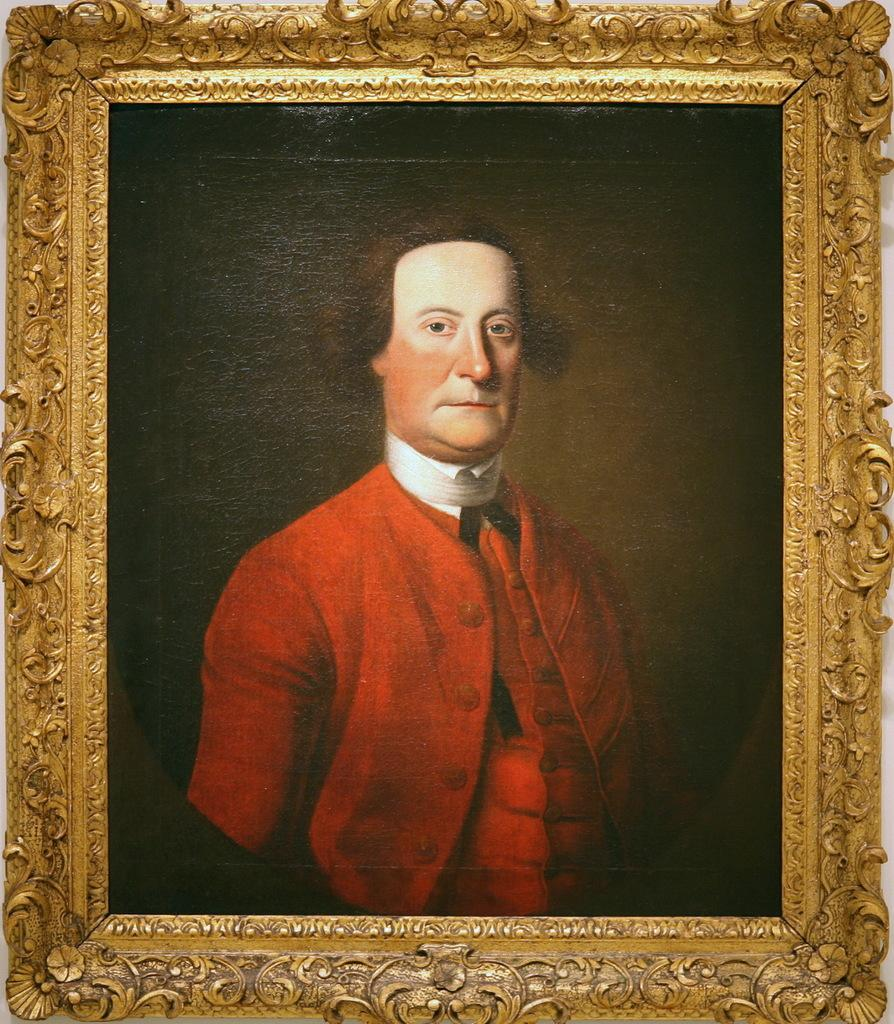What is the main object in the image? There is a frame in the image. What is depicted within the frame? The frame contains a photograph of a man. What is the man wearing in the photograph? The man is wearing a red color dress. What is the man doing in the photograph? The man is looking at the picture. How would you describe the overall lighting in the image? The background of the image is dark. How many times does the man jump in the photograph? The photograph does not depict the man jumping; he is simply looking at the picture. What type of industry is represented in the photograph? There is no industry depicted in the photograph; it features a man wearing a red dress and looking at a picture. 